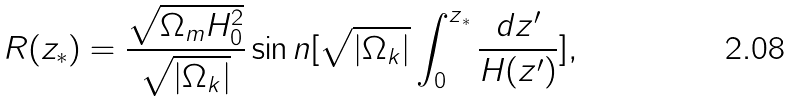Convert formula to latex. <formula><loc_0><loc_0><loc_500><loc_500>R ( z _ { \ast } ) = \frac { \sqrt { \Omega _ { m } H ^ { 2 } _ { 0 } } } { \sqrt { | \Omega _ { k } | } } \sin n [ \sqrt { | \Omega _ { k } | } \int _ { 0 } ^ { z { _ { \ast } } } \frac { d z ^ { \prime } } { H ( z ^ { \prime } ) } ] ,</formula> 